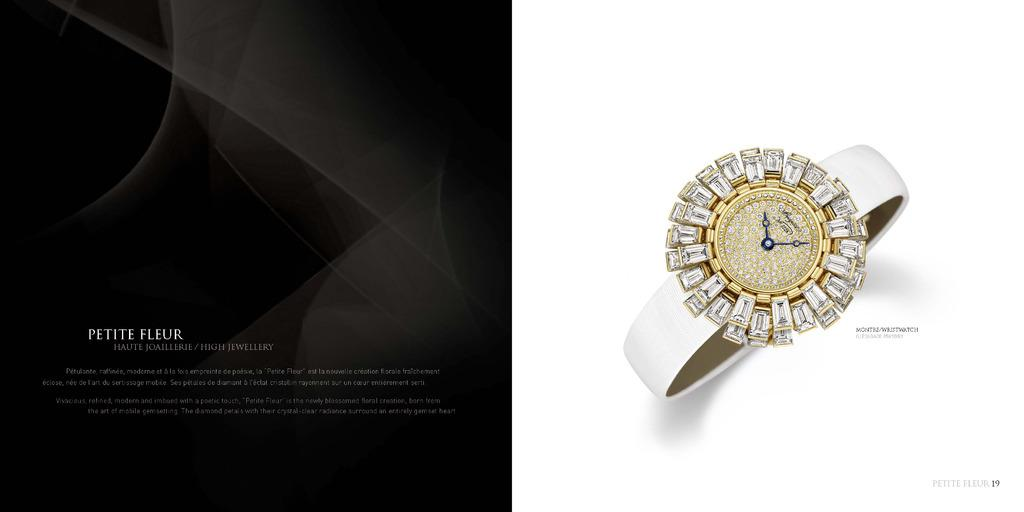<image>
Render a clear and concise summary of the photo. gold and diamond breguet no 3228 wristwatch by petite fleur 